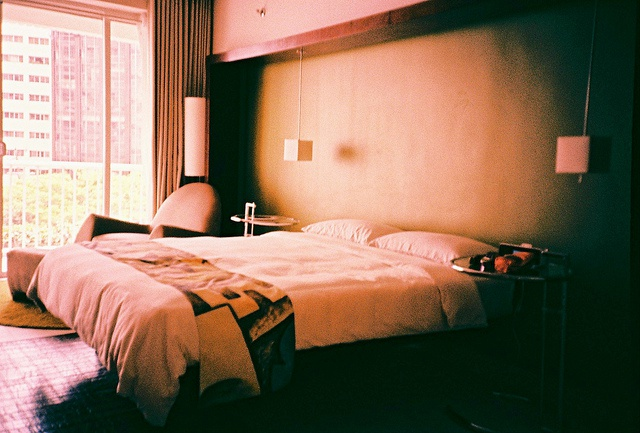Describe the objects in this image and their specific colors. I can see bed in brown, black, lightpink, and pink tones and chair in brown, lightpink, black, lightgray, and salmon tones in this image. 